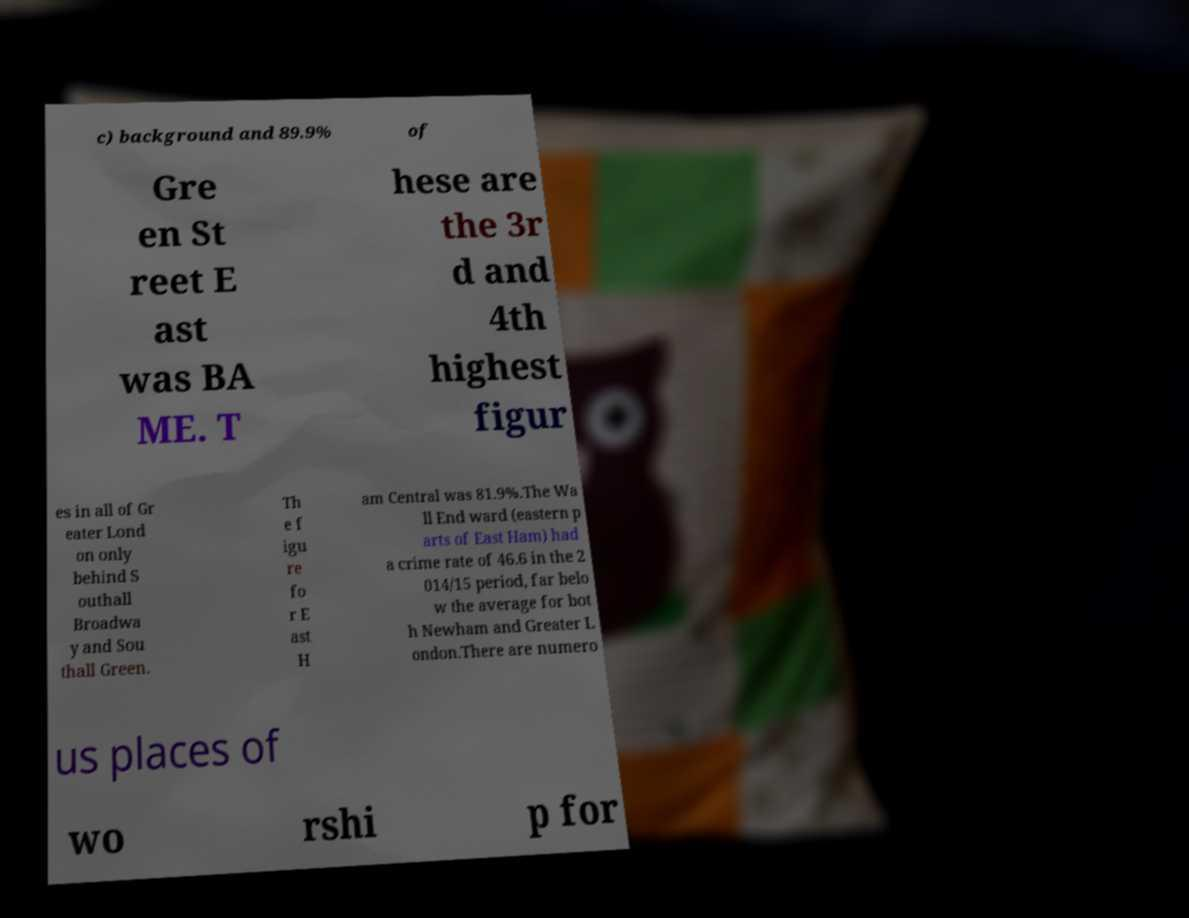I need the written content from this picture converted into text. Can you do that? c) background and 89.9% of Gre en St reet E ast was BA ME. T hese are the 3r d and 4th highest figur es in all of Gr eater Lond on only behind S outhall Broadwa y and Sou thall Green. Th e f igu re fo r E ast H am Central was 81.9%.The Wa ll End ward (eastern p arts of East Ham) had a crime rate of 46.6 in the 2 014/15 period, far belo w the average for bot h Newham and Greater L ondon.There are numero us places of wo rshi p for 